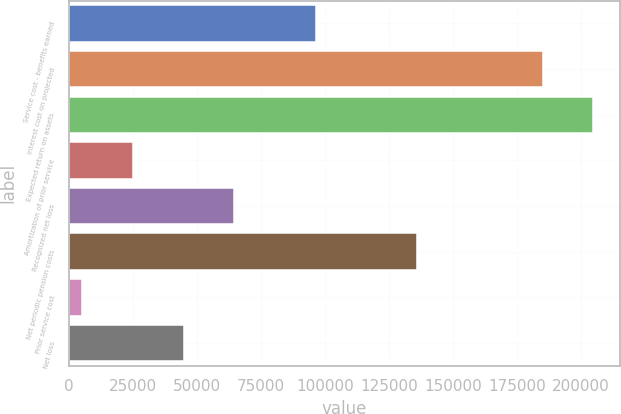Convert chart to OTSL. <chart><loc_0><loc_0><loc_500><loc_500><bar_chart><fcel>Service cost - benefits earned<fcel>Interest cost on projected<fcel>Expected return on assets<fcel>Amortization of prior service<fcel>Recognized net loss<fcel>Net periodic pension costs<fcel>Prior service cost<fcel>Net loss<nl><fcel>96565<fcel>185170<fcel>205016<fcel>24909.7<fcel>64601.1<fcel>135874<fcel>5064<fcel>44755.4<nl></chart> 